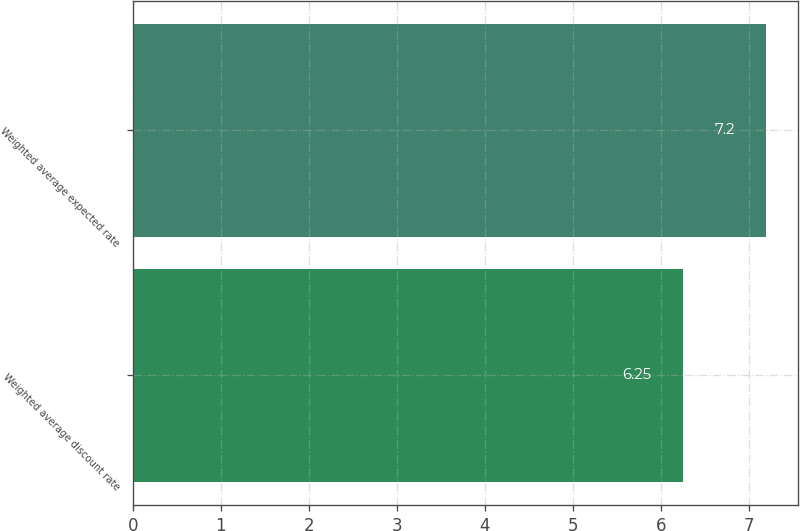<chart> <loc_0><loc_0><loc_500><loc_500><bar_chart><fcel>Weighted average discount rate<fcel>Weighted average expected rate<nl><fcel>6.25<fcel>7.2<nl></chart> 